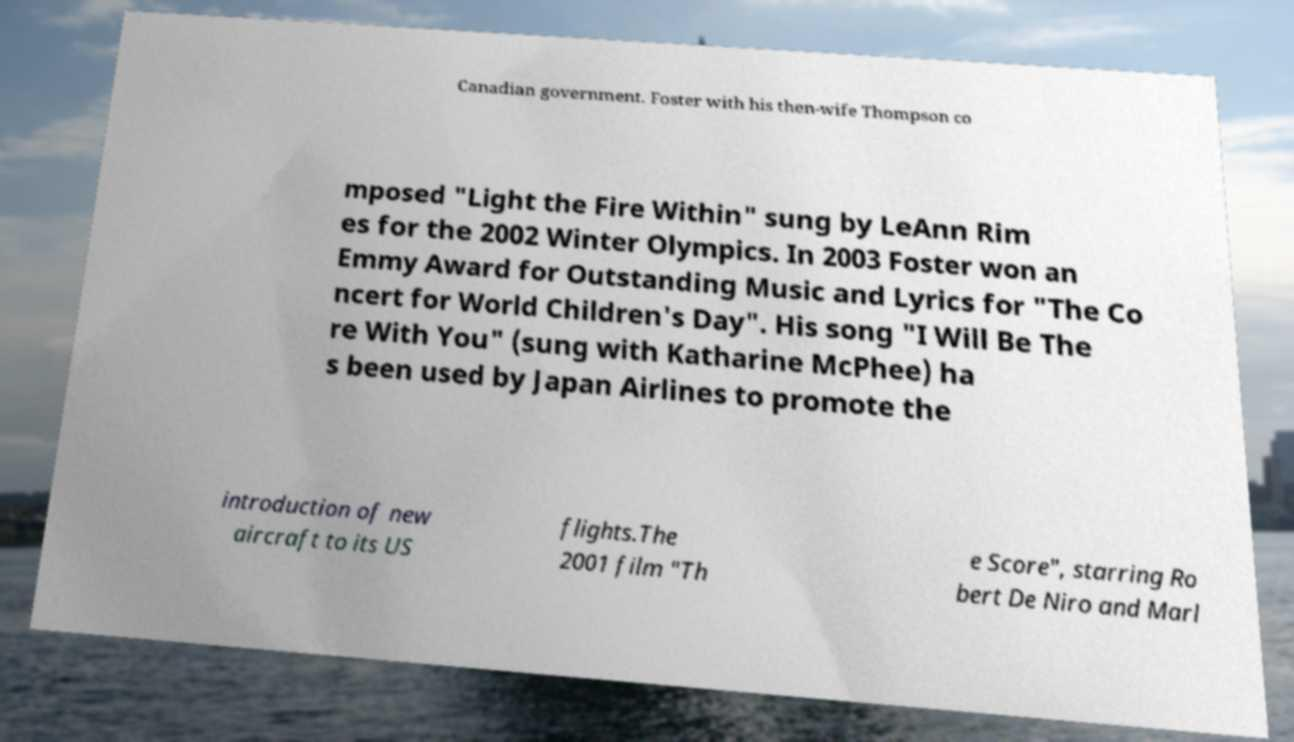What messages or text are displayed in this image? I need them in a readable, typed format. Canadian government. Foster with his then-wife Thompson co mposed "Light the Fire Within" sung by LeAnn Rim es for the 2002 Winter Olympics. In 2003 Foster won an Emmy Award for Outstanding Music and Lyrics for "The Co ncert for World Children's Day". His song "I Will Be The re With You" (sung with Katharine McPhee) ha s been used by Japan Airlines to promote the introduction of new aircraft to its US flights.The 2001 film "Th e Score", starring Ro bert De Niro and Marl 